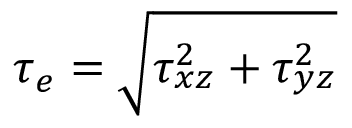<formula> <loc_0><loc_0><loc_500><loc_500>\tau _ { e } = \sqrt { \tau _ { x z } ^ { 2 } + \tau _ { y z } ^ { 2 } }</formula> 